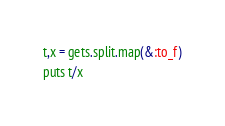<code> <loc_0><loc_0><loc_500><loc_500><_Ruby_>t,x = gets.split.map(&:to_f)
puts t/x</code> 